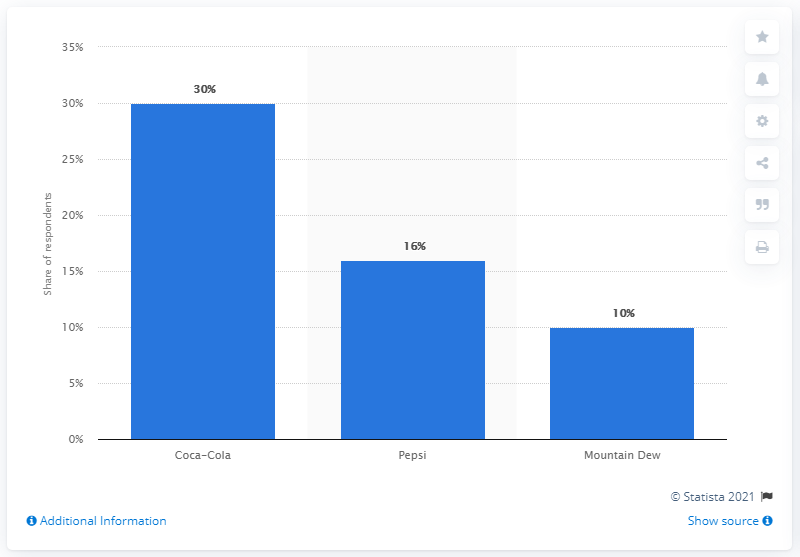Mention a couple of crucial points in this snapshot. In the past, Pepsi was the most popular soda drink for road trips. 